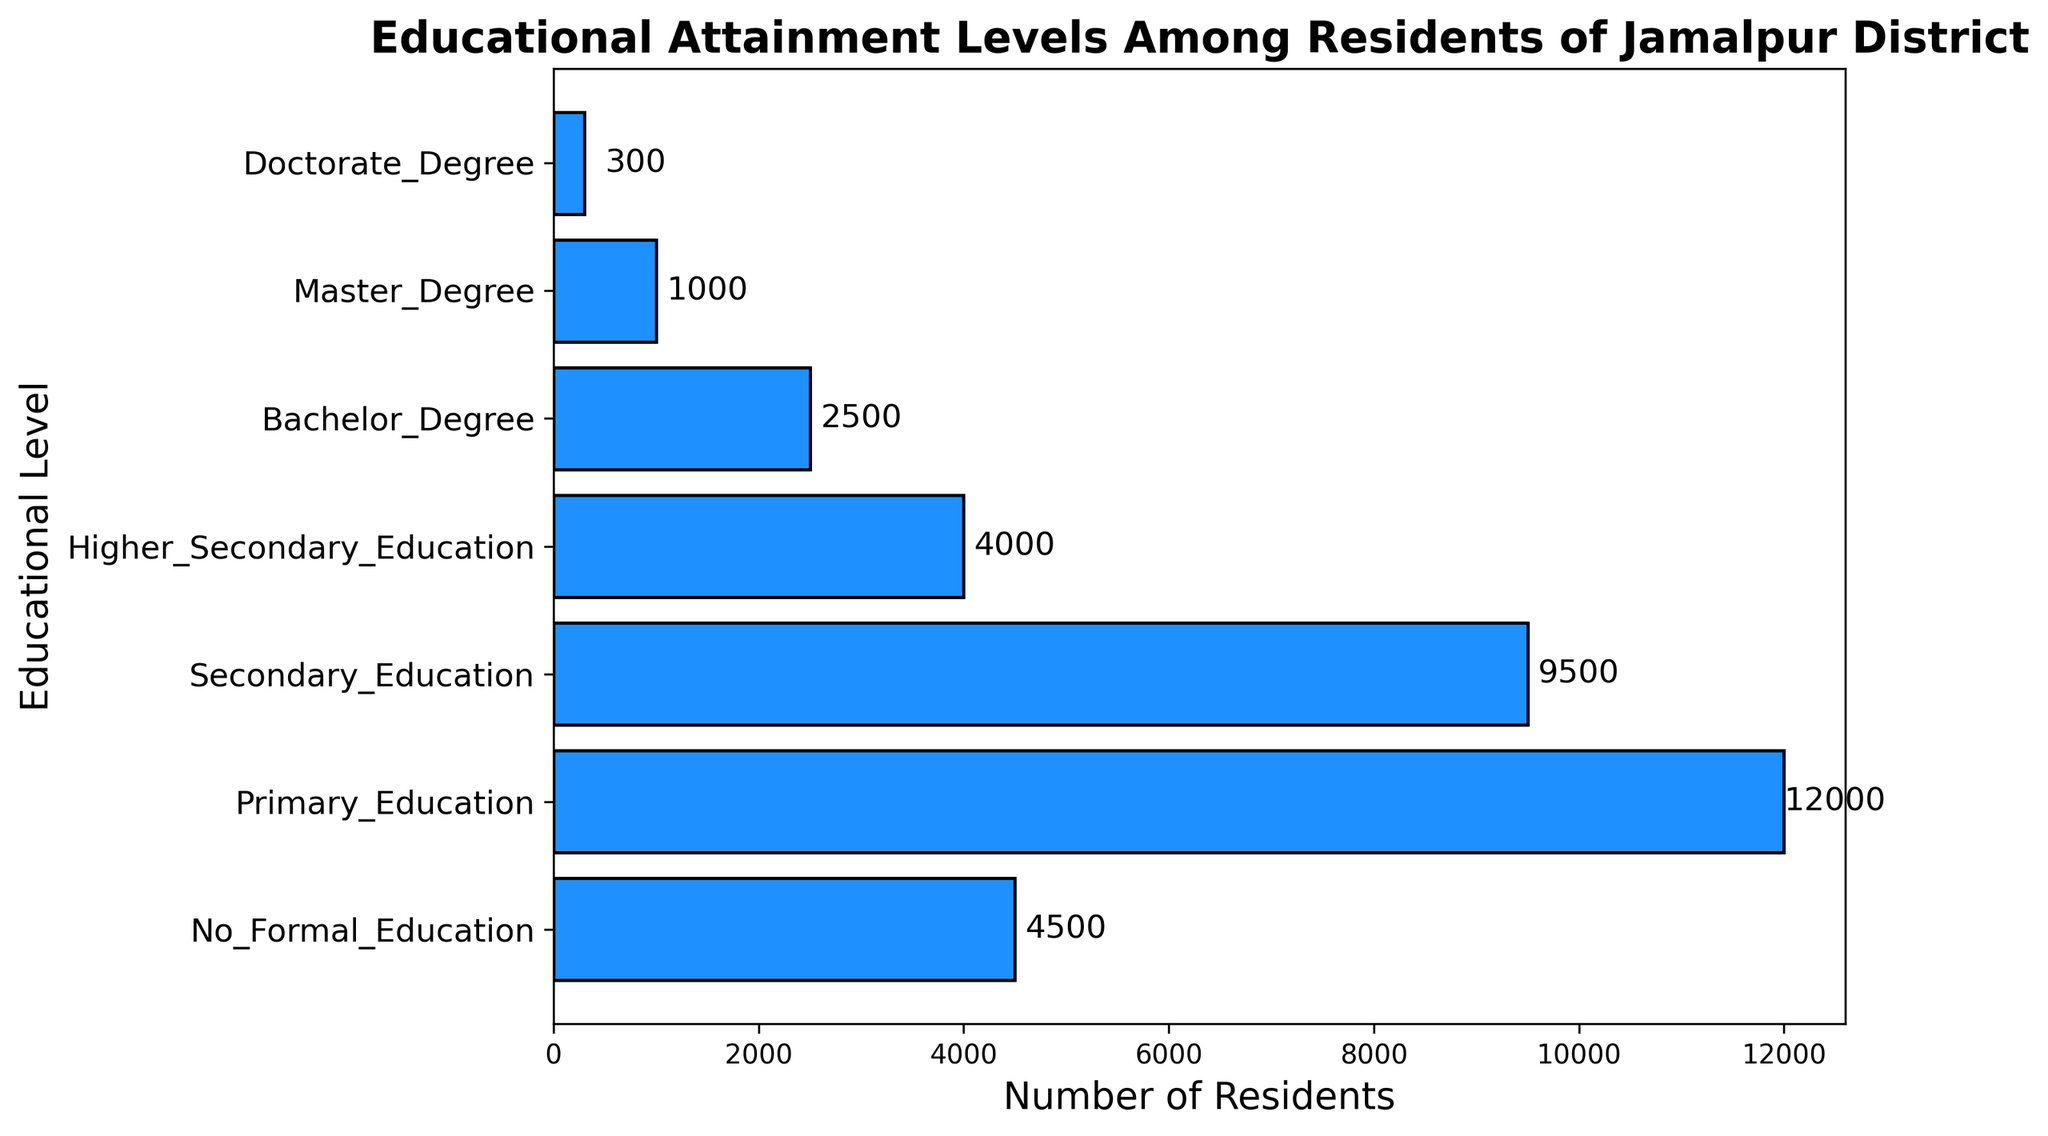What educational level has the highest number of residents? The educational level with the highest number of residents is the one with the tallest bar in the bar chart, which represents Primary Education.
Answer: Primary Education Which educational attainment level has fewer residents, Bachelor Degree or Higher Secondary Education? To compare the number of residents between Bachelor Degree and Higher Secondary Education, look at the lengths of their respective bars. The bar for Bachelor Degree is shorter than the one for Higher Secondary Education.
Answer: Bachelor Degree What is the combined number of residents with Master Degree and Doctorate Degree? Sum the number of residents for Master Degree (1000) and Doctorate Degree (300). 1000 + 300 = 1300.
Answer: 1300 How many more residents have Secondary Education compared to No Formal Education? Subtract the number of residents with No Formal Education (4500) from those with Secondary Education (9500). 9500 - 4500 = 5000.
Answer: 5000 Which two educational levels have the closest number of residents? Compare the number of residents for each educational level and find the pair with the smallest difference. Secondary Education (9500) and Primary Education (12000) have a difference of 2500, which is the closest among the levels listed.
Answer: Secondary Education and Primary Education What is the total number of residents with any level of education excluding No Formal Education? Add the number of residents for Primary Education (12000), Secondary Education (9500), Higher Secondary Education (4000), Bachelor Degree (2500), Master Degree (1000), and Doctorate Degree (300). 12000 + 9500 + 4000 + 2500 + 1000 + 300 = 29300.
Answer: 29300 What percentage of the total educated population (excluding No Formal Education) has a Bachelor Degree? First, find the total number of educated residents: 29300. Then, calculate the percentage for Bachelor Degree: (2500 / 29300) * 100 ≈ 8.53%.
Answer: 8.53% How does the number of residents with Primary Education compare to those with all higher educational levels combined (Secondary Education and above)? Sum the number of residents with Secondary Education (9500), Higher Secondary Education (4000), Bachelor Degree (2500), Master Degree (1000), and Doctorate Degree (300): 9500 + 4000 + 2500 + 1000 + 300 = 17300. Compare it to Primary Education (12000); 12000 < 17300.
Answer: Less What is the median educational level in terms of the number of residents? Arrange the educational levels by the number of residents: No Formal Education (4500), Master Degree (1000), Doctorate Degree (300), Higher Secondary Education (4000), Bachelor Degree (2500), Primary Education (12000), Secondary Education (9500). The median value is the one with the middle number of residents, which is Secondary Education.
Answer: Secondary Education 